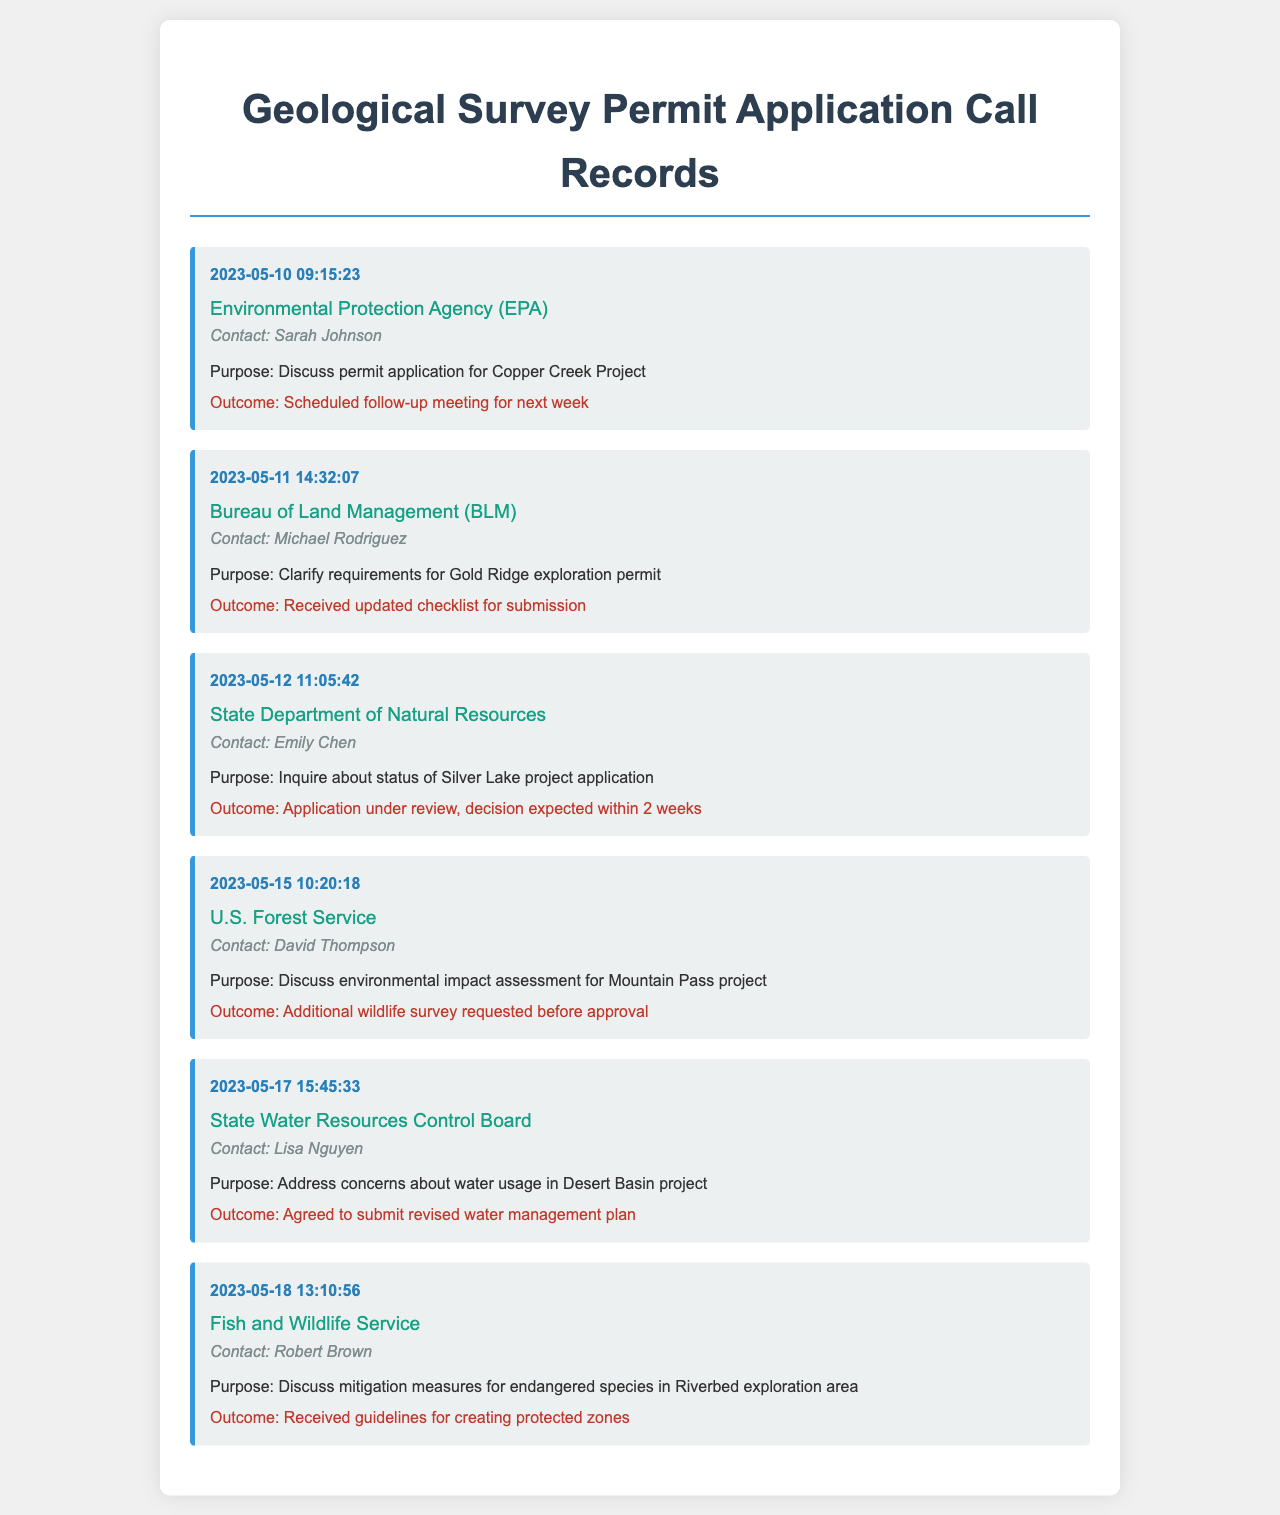What is the date of the call to the EPA? The date of the call to the EPA is found in the timestamp of the first call record.
Answer: 2023-05-10 Who was the contact for the Bureau of Land Management? The contact name for the Bureau of Land Management is provided in the second call record.
Answer: Michael Rodriguez What was the outcome of the call regarding the Silver Lake project application? The outcome for the Silver Lake project application is listed in the third call record.
Answer: Application under review, decision expected within 2 weeks How many days passed between the call to the EPA and the call to the BLM? The number of days can be calculated from the timestamps of the first two calls.
Answer: 1 day Which agency requested additional wildlife surveys? The agency that requested additional wildlife surveys is indicated in the fourth call record.
Answer: U.S. Forest Service What was discussed during the call with the Fish and Wildlife Service? The purpose of the call with the Fish and Wildlife Service is included in the sixth call record.
Answer: Discuss mitigation measures for endangered species in Riverbed exploration area 